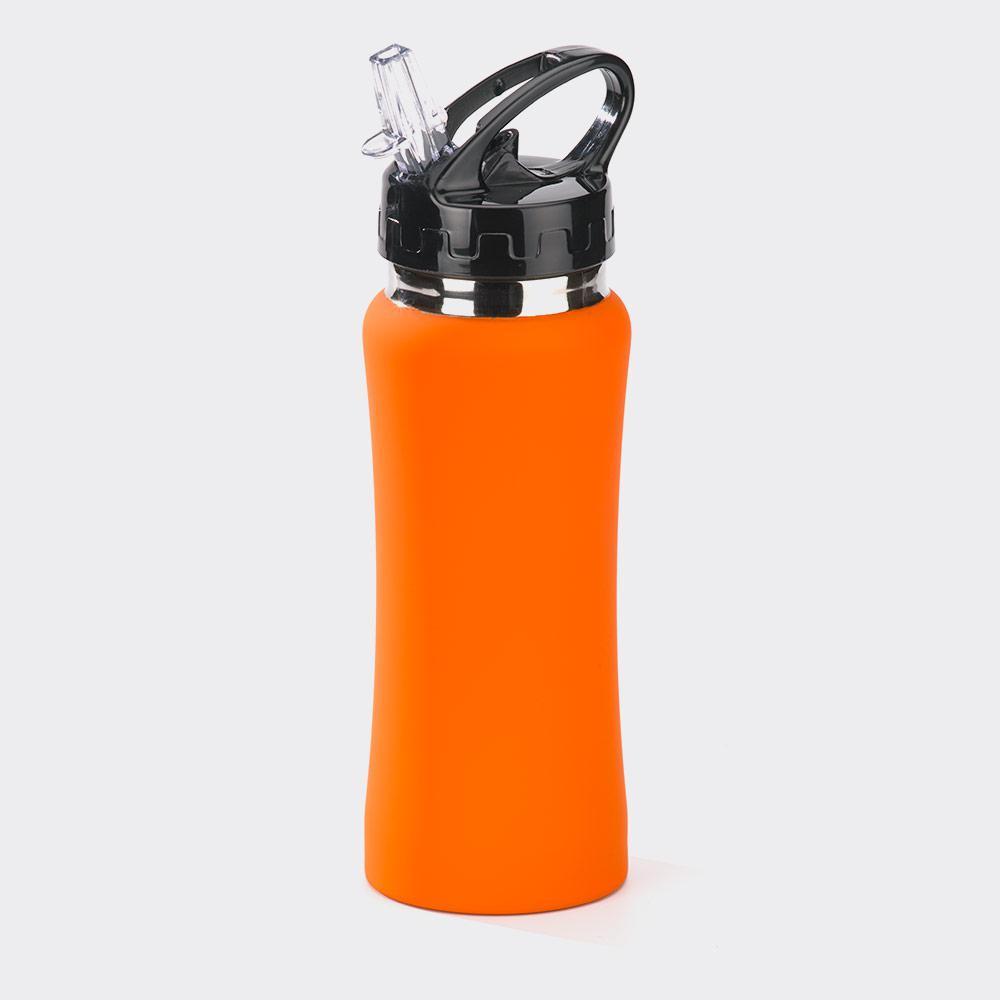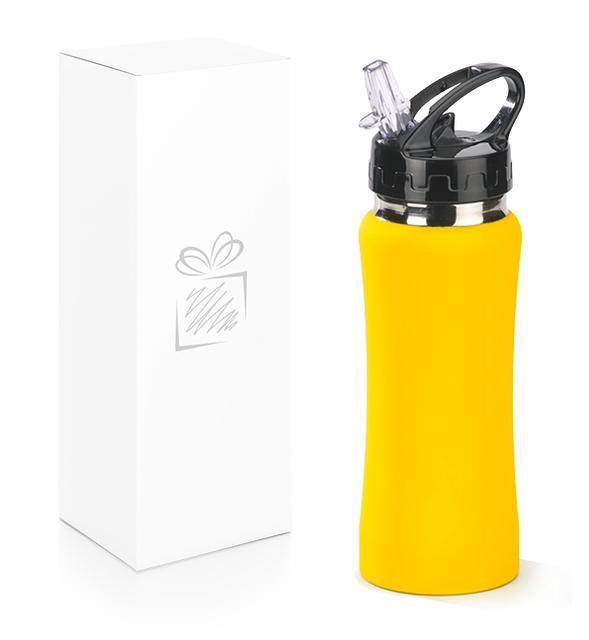The first image is the image on the left, the second image is the image on the right. Assess this claim about the two images: "There are two green bottles.". Correct or not? Answer yes or no. No. The first image is the image on the left, the second image is the image on the right. For the images displayed, is the sentence "Each image contains multiple water bottles in different solid colors, and one image shows bottles arranged in a V-formation." factually correct? Answer yes or no. No. 